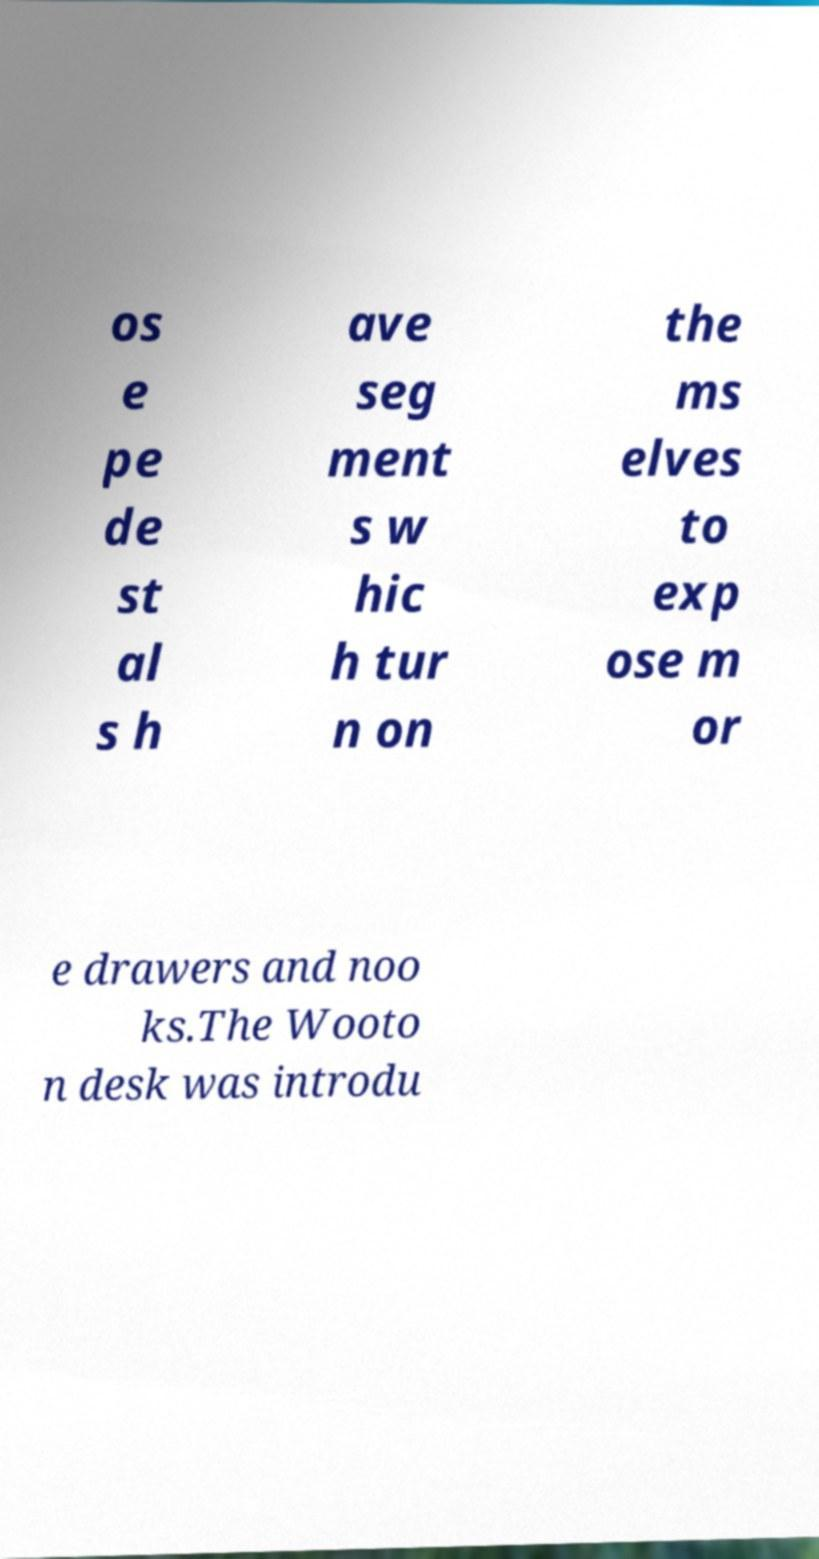Please identify and transcribe the text found in this image. os e pe de st al s h ave seg ment s w hic h tur n on the ms elves to exp ose m or e drawers and noo ks.The Wooto n desk was introdu 